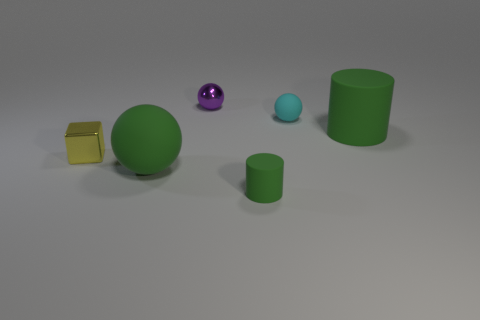There is a large ball that is the same color as the tiny rubber cylinder; what is its material?
Your answer should be compact. Rubber. Is the yellow metallic cube the same size as the purple ball?
Ensure brevity in your answer.  Yes. Is the number of green matte cylinders greater than the number of tiny cylinders?
Offer a terse response. Yes. What number of other things are the same color as the large matte cylinder?
Your answer should be compact. 2. What number of objects are tiny yellow shiny objects or small green cylinders?
Offer a terse response. 2. There is a large rubber object that is behind the yellow block; is it the same shape as the small yellow thing?
Ensure brevity in your answer.  No. There is a rubber sphere that is on the left side of the metal thing to the right of the tiny yellow metallic thing; what is its color?
Your answer should be very brief. Green. Is the number of shiny objects less than the number of tiny gray things?
Provide a short and direct response. No. Are there any small yellow spheres that have the same material as the cube?
Your response must be concise. No. There is a purple shiny object; is it the same shape as the big rubber thing that is left of the tiny green thing?
Your answer should be very brief. Yes. 